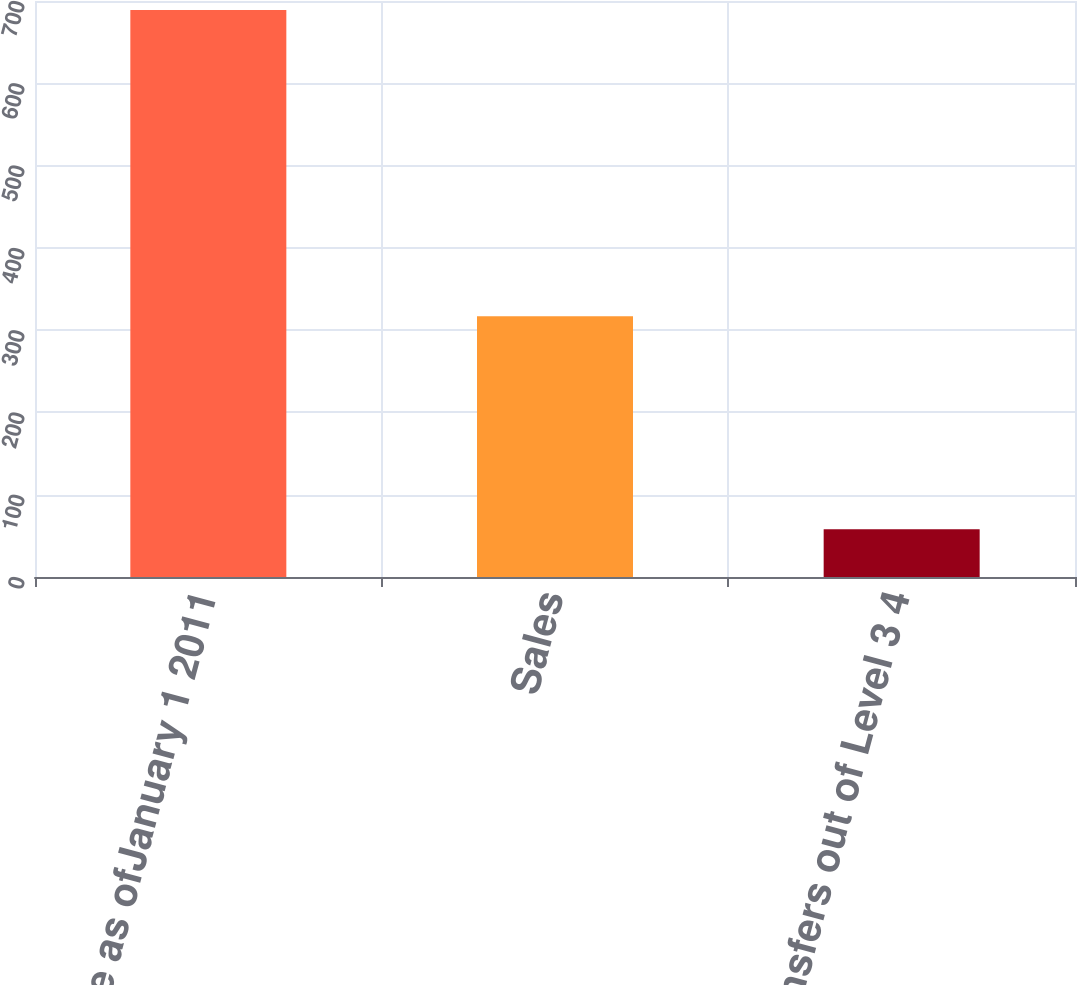Convert chart to OTSL. <chart><loc_0><loc_0><loc_500><loc_500><bar_chart><fcel>Fair value as ofJanuary 1 2011<fcel>Sales<fcel>Transfers out of Level 3 4<nl><fcel>689<fcel>317<fcel>58<nl></chart> 